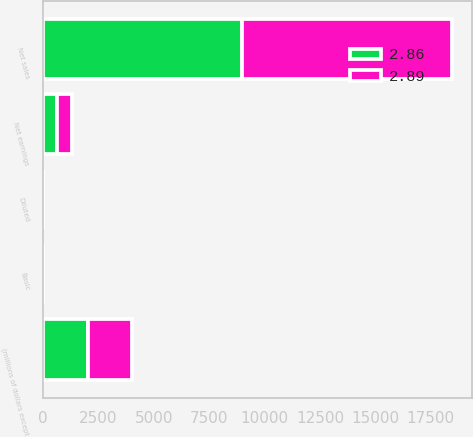<chart> <loc_0><loc_0><loc_500><loc_500><stacked_bar_chart><ecel><fcel>(millions of dollars except<fcel>Net sales<fcel>Net earnings<fcel>Basic<fcel>Diluted<nl><fcel>2.86<fcel>2015<fcel>8977.7<fcel>652<fcel>2.91<fcel>2.89<nl><fcel>2.89<fcel>2014<fcel>9487.4<fcel>653.9<fcel>2.88<fcel>2.86<nl></chart> 